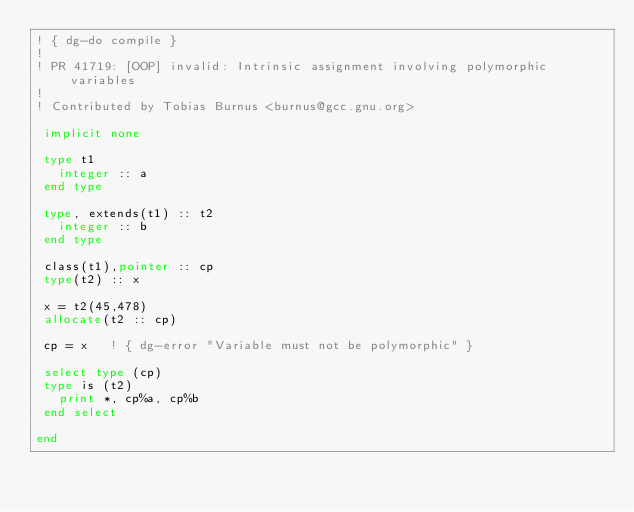<code> <loc_0><loc_0><loc_500><loc_500><_FORTRAN_>! { dg-do compile }
!
! PR 41719: [OOP] invalid: Intrinsic assignment involving polymorphic variables
!
! Contributed by Tobias Burnus <burnus@gcc.gnu.org>

 implicit none

 type t1
   integer :: a
 end type

 type, extends(t1) :: t2
   integer :: b
 end type

 class(t1),pointer :: cp
 type(t2) :: x

 x = t2(45,478)
 allocate(t2 :: cp)

 cp = x   ! { dg-error "Variable must not be polymorphic" }

 select type (cp)
 type is (t2)
   print *, cp%a, cp%b
 end select

end
 </code> 